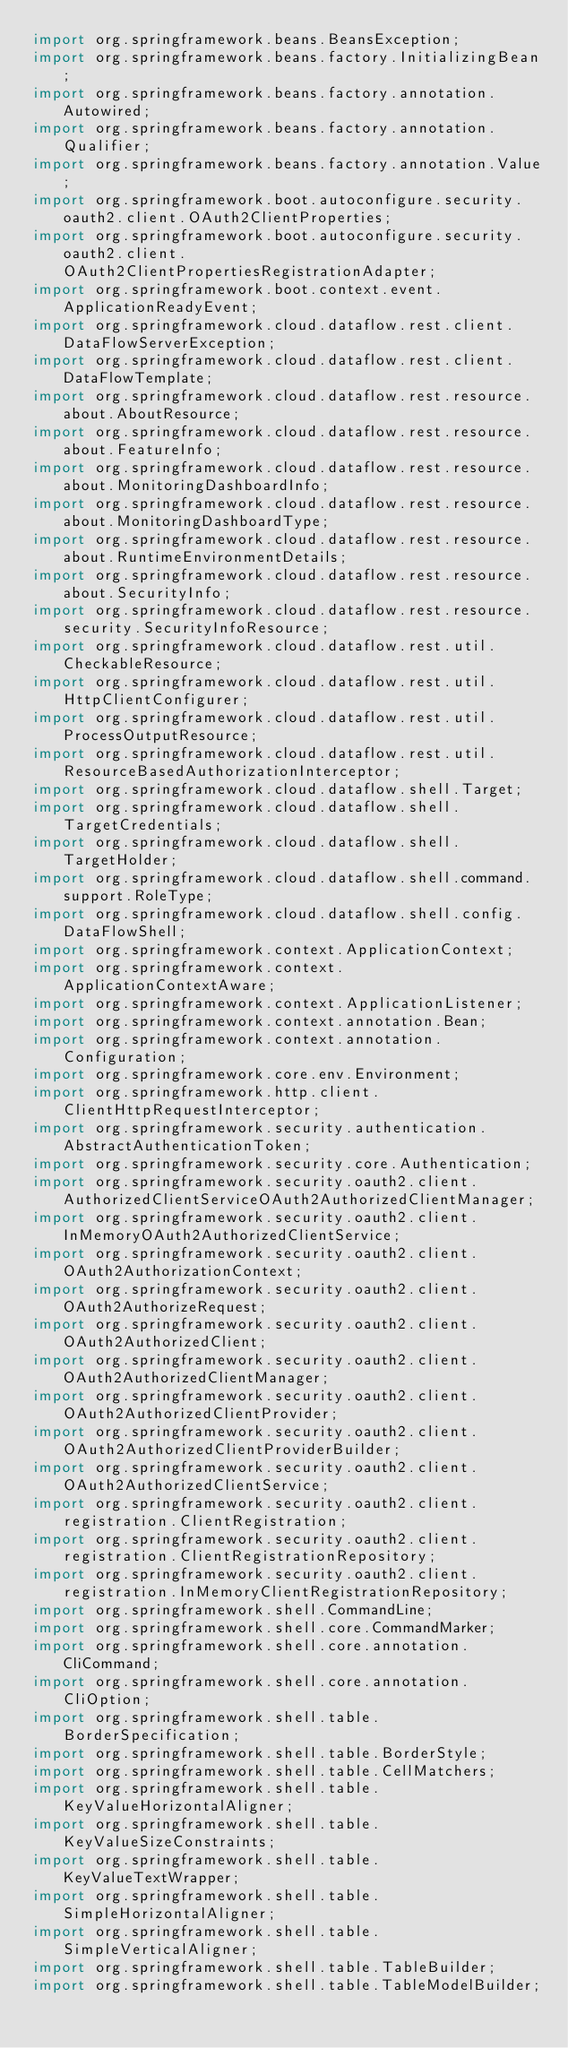<code> <loc_0><loc_0><loc_500><loc_500><_Java_>import org.springframework.beans.BeansException;
import org.springframework.beans.factory.InitializingBean;
import org.springframework.beans.factory.annotation.Autowired;
import org.springframework.beans.factory.annotation.Qualifier;
import org.springframework.beans.factory.annotation.Value;
import org.springframework.boot.autoconfigure.security.oauth2.client.OAuth2ClientProperties;
import org.springframework.boot.autoconfigure.security.oauth2.client.OAuth2ClientPropertiesRegistrationAdapter;
import org.springframework.boot.context.event.ApplicationReadyEvent;
import org.springframework.cloud.dataflow.rest.client.DataFlowServerException;
import org.springframework.cloud.dataflow.rest.client.DataFlowTemplate;
import org.springframework.cloud.dataflow.rest.resource.about.AboutResource;
import org.springframework.cloud.dataflow.rest.resource.about.FeatureInfo;
import org.springframework.cloud.dataflow.rest.resource.about.MonitoringDashboardInfo;
import org.springframework.cloud.dataflow.rest.resource.about.MonitoringDashboardType;
import org.springframework.cloud.dataflow.rest.resource.about.RuntimeEnvironmentDetails;
import org.springframework.cloud.dataflow.rest.resource.about.SecurityInfo;
import org.springframework.cloud.dataflow.rest.resource.security.SecurityInfoResource;
import org.springframework.cloud.dataflow.rest.util.CheckableResource;
import org.springframework.cloud.dataflow.rest.util.HttpClientConfigurer;
import org.springframework.cloud.dataflow.rest.util.ProcessOutputResource;
import org.springframework.cloud.dataflow.rest.util.ResourceBasedAuthorizationInterceptor;
import org.springframework.cloud.dataflow.shell.Target;
import org.springframework.cloud.dataflow.shell.TargetCredentials;
import org.springframework.cloud.dataflow.shell.TargetHolder;
import org.springframework.cloud.dataflow.shell.command.support.RoleType;
import org.springframework.cloud.dataflow.shell.config.DataFlowShell;
import org.springframework.context.ApplicationContext;
import org.springframework.context.ApplicationContextAware;
import org.springframework.context.ApplicationListener;
import org.springframework.context.annotation.Bean;
import org.springframework.context.annotation.Configuration;
import org.springframework.core.env.Environment;
import org.springframework.http.client.ClientHttpRequestInterceptor;
import org.springframework.security.authentication.AbstractAuthenticationToken;
import org.springframework.security.core.Authentication;
import org.springframework.security.oauth2.client.AuthorizedClientServiceOAuth2AuthorizedClientManager;
import org.springframework.security.oauth2.client.InMemoryOAuth2AuthorizedClientService;
import org.springframework.security.oauth2.client.OAuth2AuthorizationContext;
import org.springframework.security.oauth2.client.OAuth2AuthorizeRequest;
import org.springframework.security.oauth2.client.OAuth2AuthorizedClient;
import org.springframework.security.oauth2.client.OAuth2AuthorizedClientManager;
import org.springframework.security.oauth2.client.OAuth2AuthorizedClientProvider;
import org.springframework.security.oauth2.client.OAuth2AuthorizedClientProviderBuilder;
import org.springframework.security.oauth2.client.OAuth2AuthorizedClientService;
import org.springframework.security.oauth2.client.registration.ClientRegistration;
import org.springframework.security.oauth2.client.registration.ClientRegistrationRepository;
import org.springframework.security.oauth2.client.registration.InMemoryClientRegistrationRepository;
import org.springframework.shell.CommandLine;
import org.springframework.shell.core.CommandMarker;
import org.springframework.shell.core.annotation.CliCommand;
import org.springframework.shell.core.annotation.CliOption;
import org.springframework.shell.table.BorderSpecification;
import org.springframework.shell.table.BorderStyle;
import org.springframework.shell.table.CellMatchers;
import org.springframework.shell.table.KeyValueHorizontalAligner;
import org.springframework.shell.table.KeyValueSizeConstraints;
import org.springframework.shell.table.KeyValueTextWrapper;
import org.springframework.shell.table.SimpleHorizontalAligner;
import org.springframework.shell.table.SimpleVerticalAligner;
import org.springframework.shell.table.TableBuilder;
import org.springframework.shell.table.TableModelBuilder;</code> 